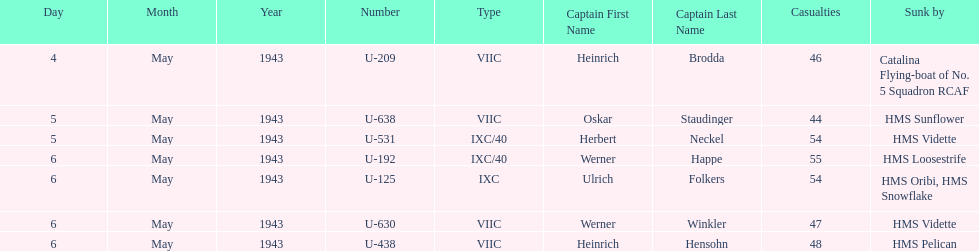Which sunken u-boat had the most casualties U-192. 